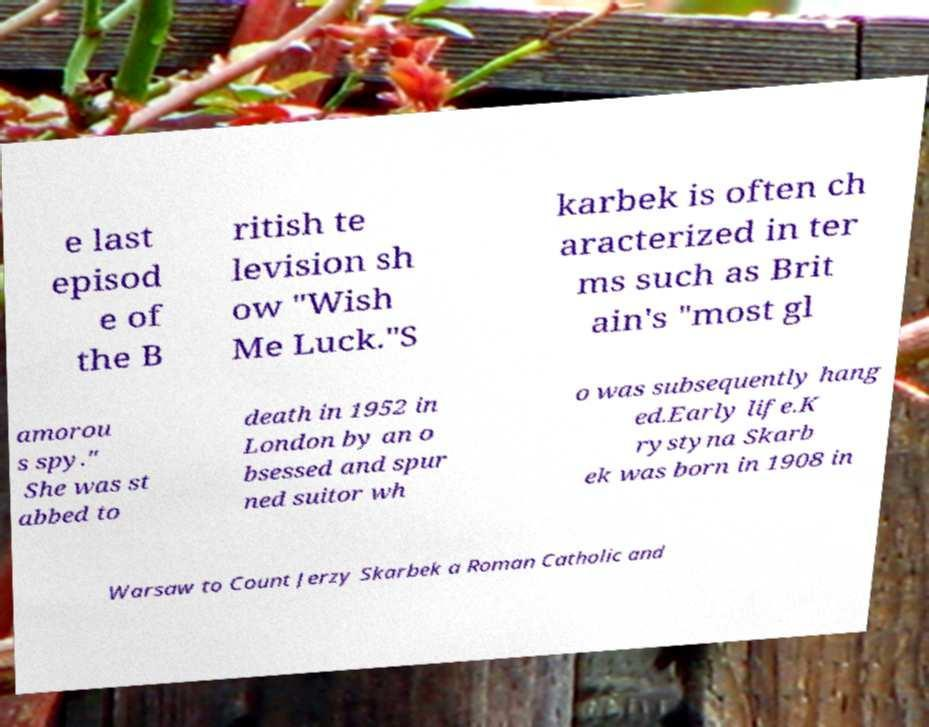What messages or text are displayed in this image? I need them in a readable, typed format. e last episod e of the B ritish te levision sh ow "Wish Me Luck."S karbek is often ch aracterized in ter ms such as Brit ain's "most gl amorou s spy." She was st abbed to death in 1952 in London by an o bsessed and spur ned suitor wh o was subsequently hang ed.Early life.K rystyna Skarb ek was born in 1908 in Warsaw to Count Jerzy Skarbek a Roman Catholic and 